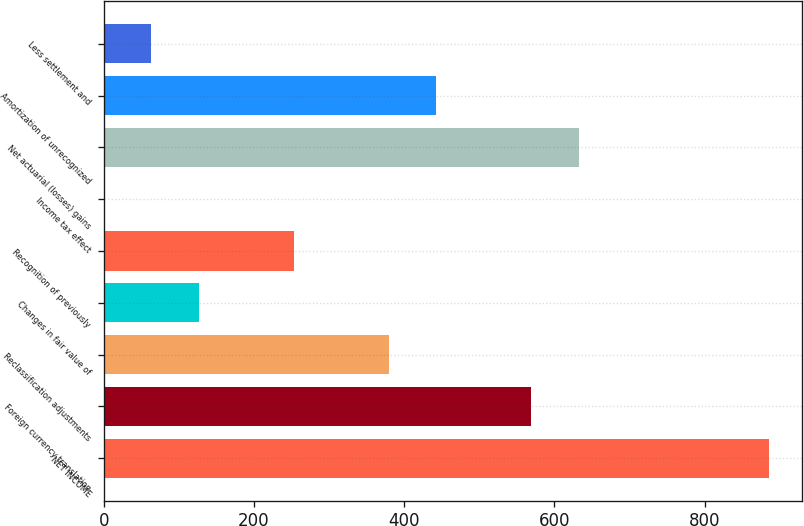Convert chart to OTSL. <chart><loc_0><loc_0><loc_500><loc_500><bar_chart><fcel>NET INCOME<fcel>Foreign currency translation<fcel>Reclassification adjustments<fcel>Changes in fair value of<fcel>Recognition of previously<fcel>Income tax effect<fcel>Net actuarial (losses) gains<fcel>Amortization of unrecognized<fcel>Less settlement and<nl><fcel>885.46<fcel>569.26<fcel>379.54<fcel>126.58<fcel>253.06<fcel>0.1<fcel>632.5<fcel>442.78<fcel>63.34<nl></chart> 